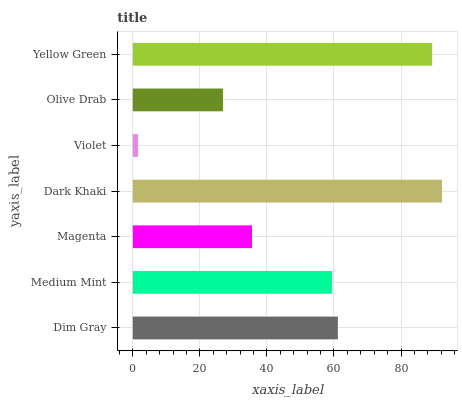Is Violet the minimum?
Answer yes or no. Yes. Is Dark Khaki the maximum?
Answer yes or no. Yes. Is Medium Mint the minimum?
Answer yes or no. No. Is Medium Mint the maximum?
Answer yes or no. No. Is Dim Gray greater than Medium Mint?
Answer yes or no. Yes. Is Medium Mint less than Dim Gray?
Answer yes or no. Yes. Is Medium Mint greater than Dim Gray?
Answer yes or no. No. Is Dim Gray less than Medium Mint?
Answer yes or no. No. Is Medium Mint the high median?
Answer yes or no. Yes. Is Medium Mint the low median?
Answer yes or no. Yes. Is Olive Drab the high median?
Answer yes or no. No. Is Yellow Green the low median?
Answer yes or no. No. 